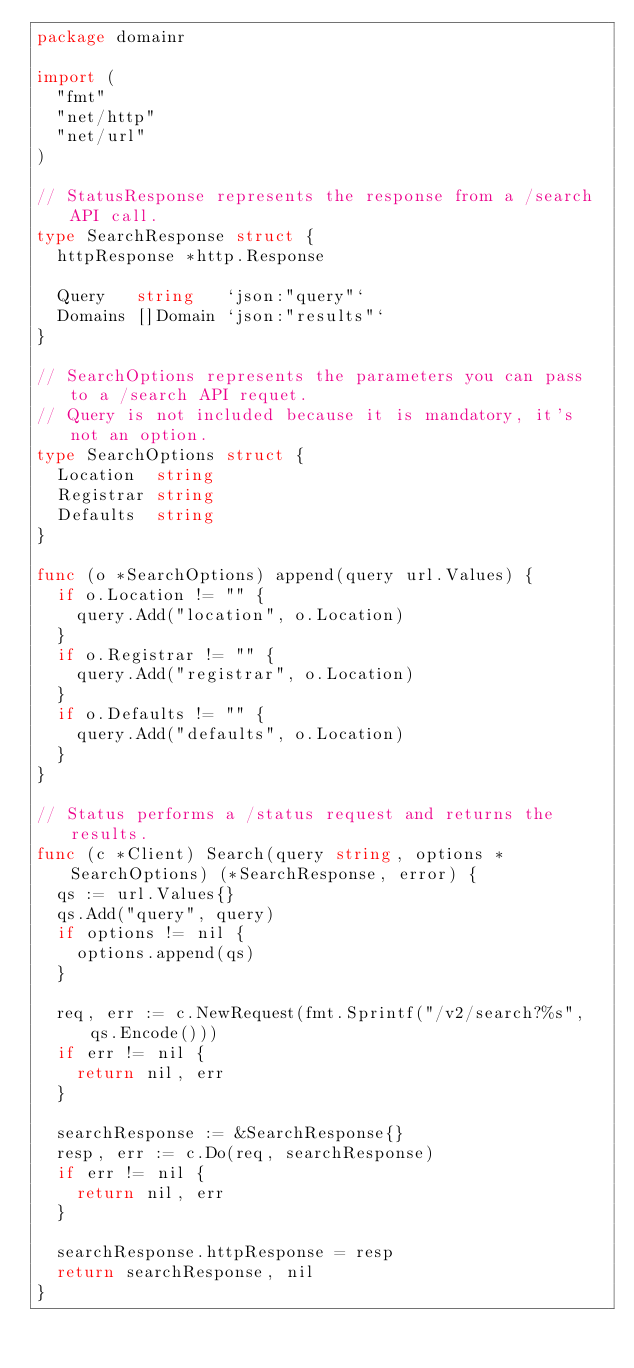Convert code to text. <code><loc_0><loc_0><loc_500><loc_500><_Go_>package domainr

import (
	"fmt"
	"net/http"
	"net/url"
)

// StatusResponse represents the response from a /search API call.
type SearchResponse struct {
	httpResponse *http.Response

	Query   string   `json:"query"`
	Domains []Domain `json:"results"`
}

// SearchOptions represents the parameters you can pass to a /search API requet.
// Query is not included because it is mandatory, it's not an option.
type SearchOptions struct {
	Location  string
	Registrar string
	Defaults  string
}

func (o *SearchOptions) append(query url.Values) {
	if o.Location != "" {
		query.Add("location", o.Location)
	}
	if o.Registrar != "" {
		query.Add("registrar", o.Location)
	}
	if o.Defaults != "" {
		query.Add("defaults", o.Location)
	}
}

// Status performs a /status request and returns the results.
func (c *Client) Search(query string, options *SearchOptions) (*SearchResponse, error) {
	qs := url.Values{}
	qs.Add("query", query)
	if options != nil {
		options.append(qs)
	}

	req, err := c.NewRequest(fmt.Sprintf("/v2/search?%s", qs.Encode()))
	if err != nil {
		return nil, err
	}

	searchResponse := &SearchResponse{}
	resp, err := c.Do(req, searchResponse)
	if err != nil {
		return nil, err
	}

	searchResponse.httpResponse = resp
	return searchResponse, nil
}
</code> 